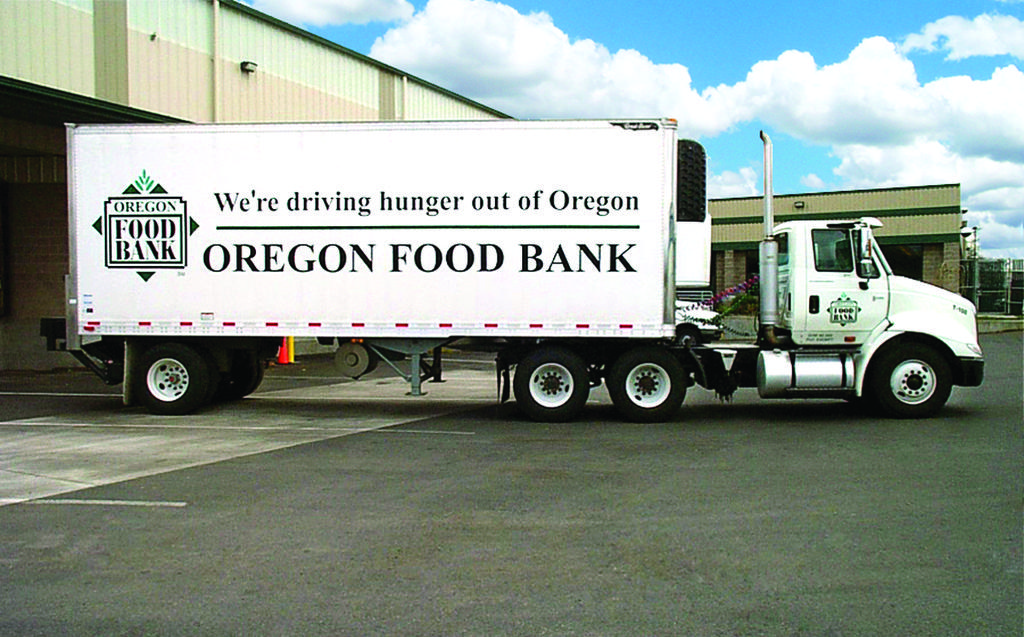What type of vehicle is on the road in the image? There is a truck on the road in the image. What type of structures can be seen in the image? There are sheds in the image. What type of vegetation is visible in the image? There are trees in the image. What is visible in the background of the image? The sky is visible in the background of the image. What can be seen in the sky in the background of the image? There are clouds in the sky in the background of the image. What type of corn is being tested in the image? There is no corn present in the image, and therefore no such testing can be observed. What type of fowl can be seen walking around in the image? There is no fowl present in the image, and therefore no such walking can be observed. 